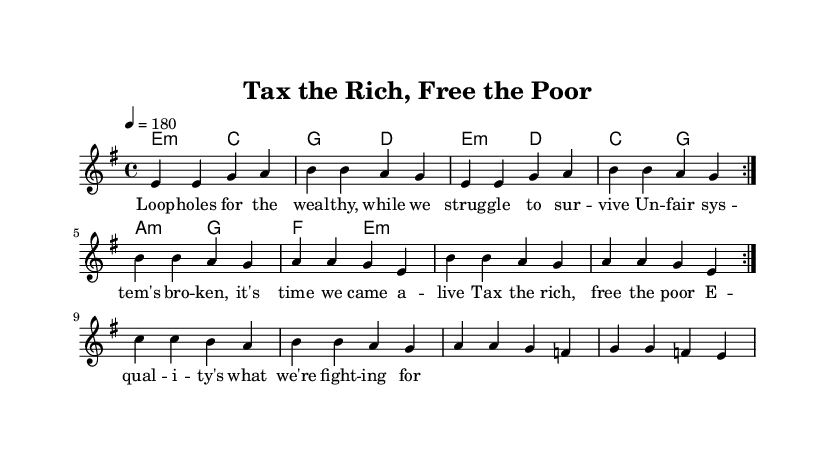What is the key signature of this music? The key signature shows one sharp, indicating E minor.
Answer: E minor What is the time signature of this piece? The time signature is indicated by the "4/4" on the sheet, meaning there are four beats per measure.
Answer: 4/4 What is the tempo marking for this piece? The tempo indication is marked as "4 = 180," meaning there are 180 quarter-note beats per minute.
Answer: 180 How many measures are in the first section of the melody? By counting the measures in the repeated volta section of the melody, there are eight measures.
Answer: Eight What is the main theme of the lyrics? The lyrics focus on challenging unfair systems and advocating for income equality through the refrain "Tax the rich, free the poor."
Answer: Tax the rich, free the poor What kind of chords are used in the harmony section? The harmony section predominantly uses minor chords as indicated by "m" in the chord names.
Answer: Minor chords Why is the repeated volta significant in punk music? The repeated volta emphasizes the urgency and intensity of the message against tax loopholes, aligning with punk’s anti-establishment roots.
Answer: Urgency and intensity 